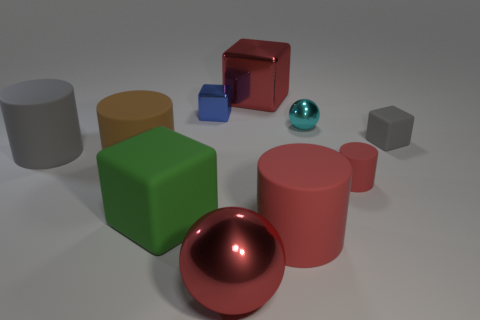Subtract all brown blocks. Subtract all red balls. How many blocks are left? 4 Subtract all cubes. How many objects are left? 6 Subtract 0 green spheres. How many objects are left? 10 Subtract all metal objects. Subtract all tiny metal balls. How many objects are left? 5 Add 6 large red shiny things. How many large red shiny things are left? 8 Add 1 brown rubber things. How many brown rubber things exist? 2 